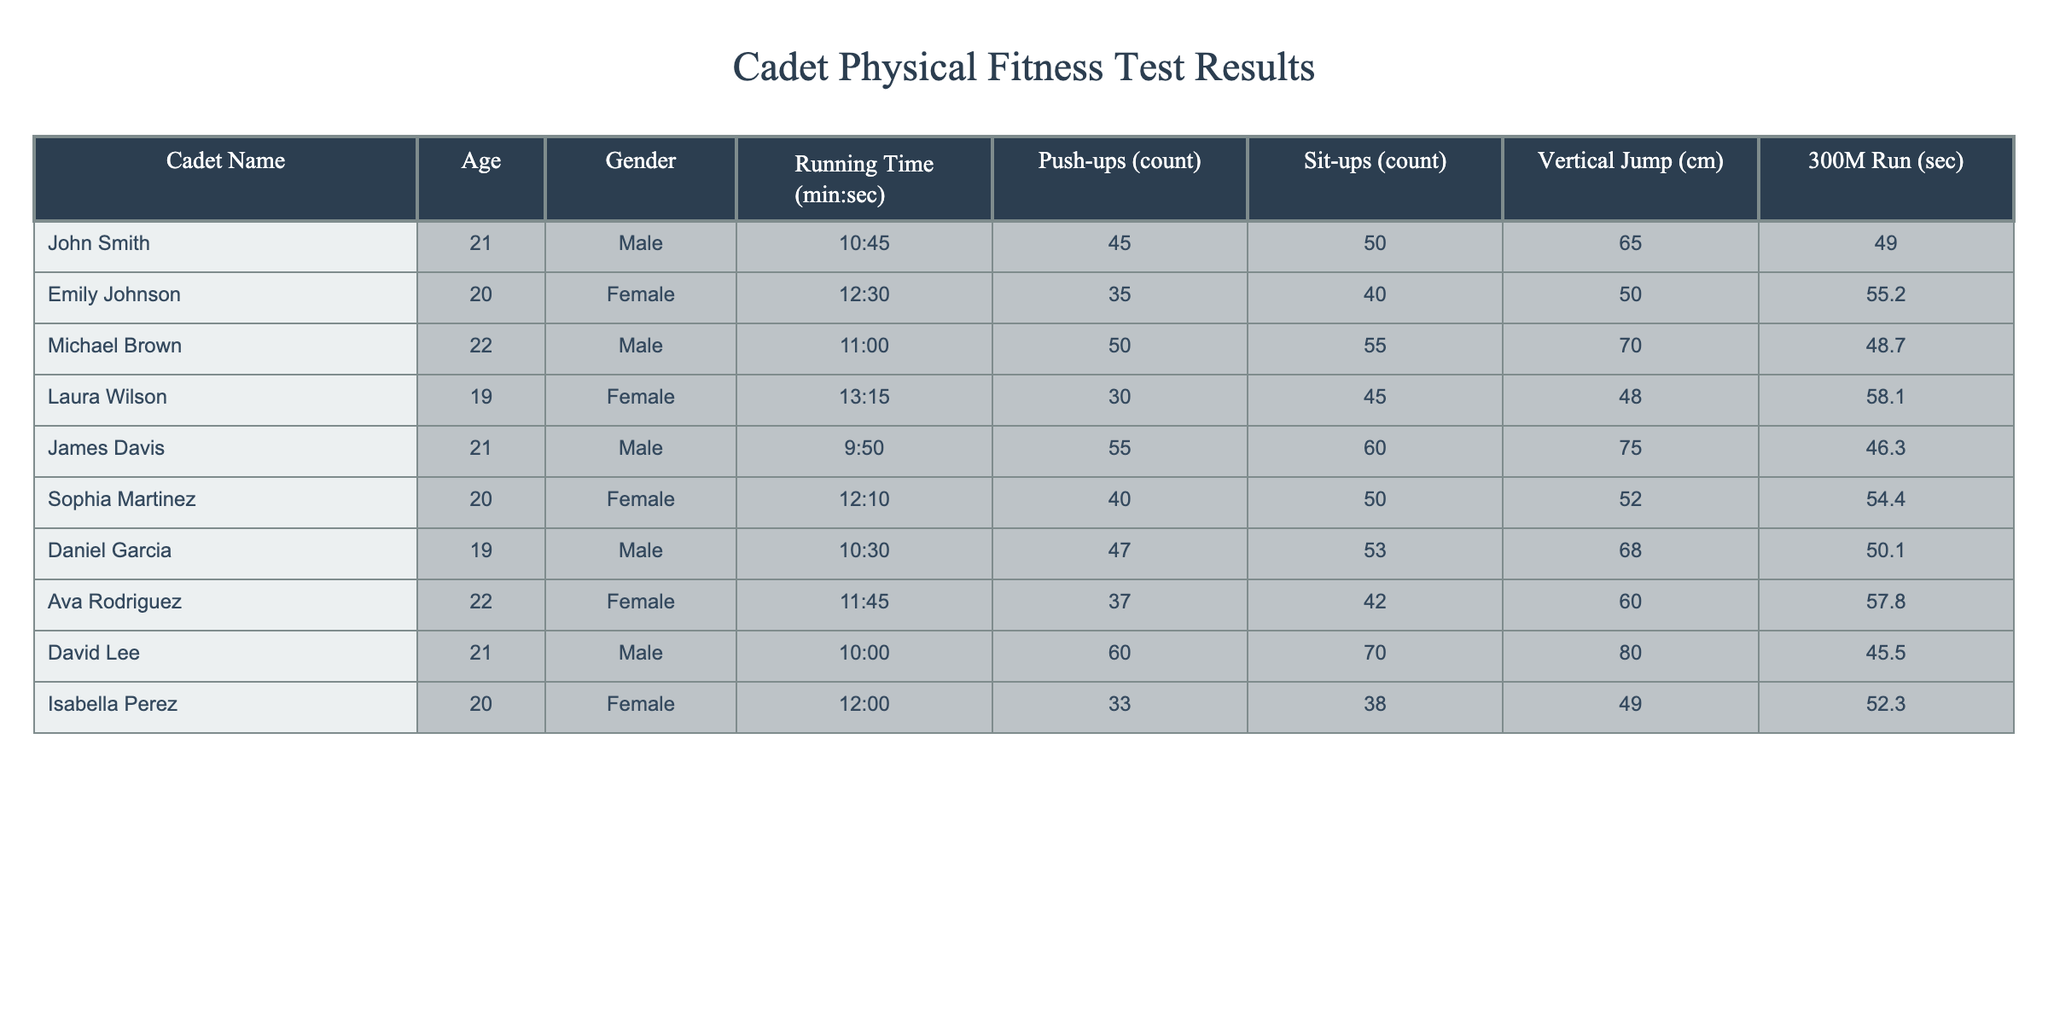What is the fastest running time among the cadets? The running times listed for each cadet need to be compared. The fastest time is 9:50 by James Davis.
Answer: 9:50 How many push-ups did Daniel Garcia complete? The column for push-ups indicates that Daniel Garcia performed 47 push-ups.
Answer: 47 Who is the oldest cadet in the table? The ages of the cadets are examined, and Michael Brown is 22 years old, making him the oldest in the group.
Answer: Michael Brown What is the average sit-up count of all the cadets? The sit-up counts for all cadets add up to 408. Dividing this by the number of cadets (10) gives an average of 40.8 sit-ups.
Answer: 40.8 Did any female cadet perform more than 50 sit-ups? By reviewing the sit-up counts for female cadets, only Sophia Martinez and Laura Wilson performed less than or equal to 50 sit-ups, so the statement is false.
Answer: No Which male cadet had the highest vertical jump? The vertical jump heights for male cadets are checked, and it shows that David Lee achieved the highest at 80 cm.
Answer: David Lee What is the difference in running times between the fastest and the slowest cadets? The fastest running time is 9:50 (James Davis), while the slowest is 13:15 (Laura Wilson). The difference is calculated as (13:15 - 9:50), which translates to 3 minutes and 25 seconds.
Answer: 3:25 Are there more males than females among the cadets? The table lists 6 male cadets (John, Michael, James, Daniel, David) and 4 female cadets (Emily, Laura, Sophia, Ava, Isabella). Since 6 is greater than 4, the statement is true.
Answer: Yes What is the median time for the 300M run event among the cadets? The 300M run times are arranged in order: 45.5, 46.3, 48.7, 49.0, 50.1, 52.3, 54.4, 55.2, 57.8, 58.1. The median for 10 values is the average of the 5th and 6th times: (50.1 + 52.3)/2 = 51.2 seconds.
Answer: 51.2 